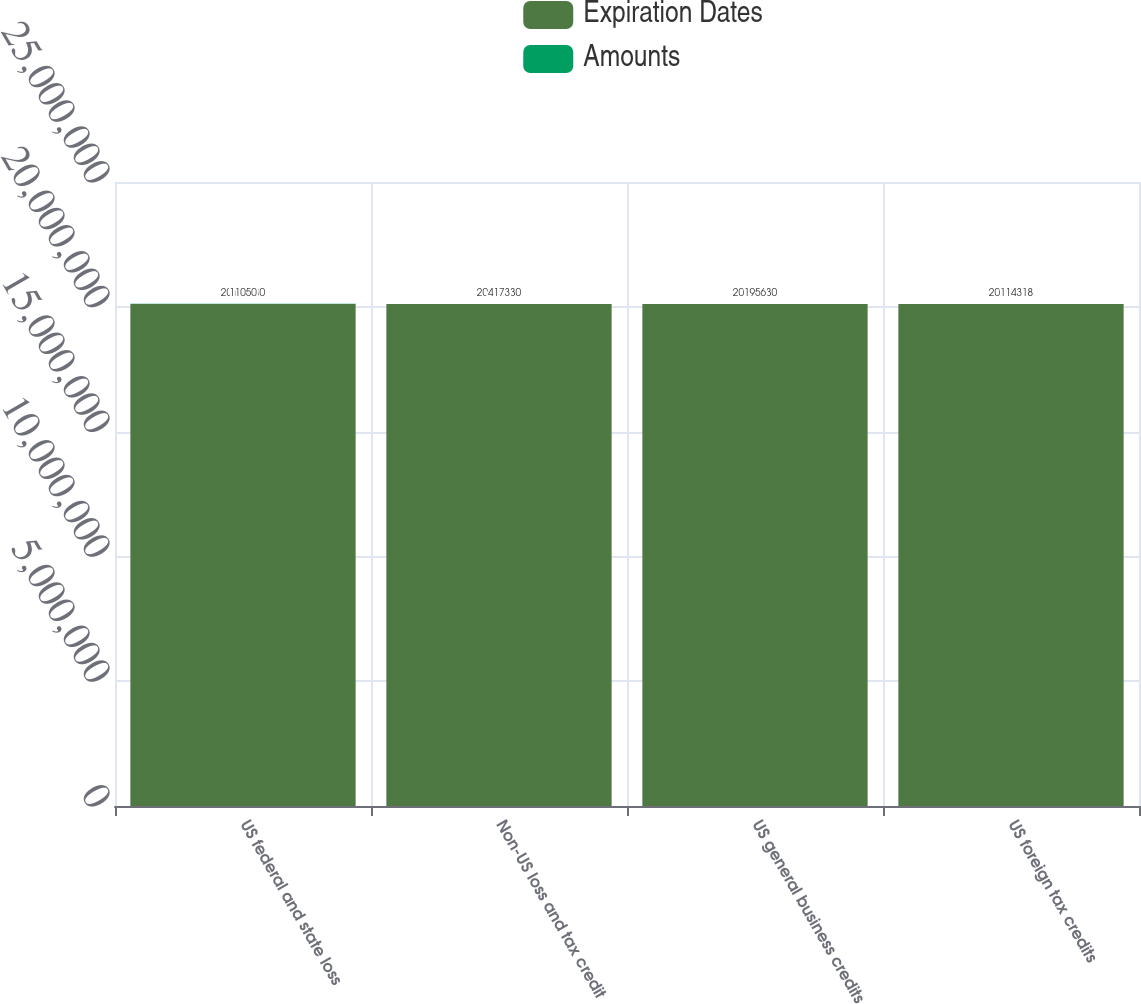Convert chart. <chart><loc_0><loc_0><loc_500><loc_500><stacked_bar_chart><ecel><fcel>US federal and state loss<fcel>Non-US loss and tax credit<fcel>US general business credits<fcel>US foreign tax credits<nl><fcel>Expiration Dates<fcel>2.0112e+07<fcel>2.0112e+07<fcel>2.0112e+07<fcel>2.0112e+07<nl><fcel>Amounts<fcel>11050<fcel>4173<fcel>1956<fcel>1143<nl></chart> 